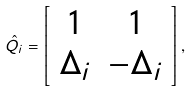Convert formula to latex. <formula><loc_0><loc_0><loc_500><loc_500>\hat { Q } _ { i } = \left [ \begin{array} { c c } 1 & 1 \\ \Delta _ { i } & - \Delta _ { i } \end{array} \right ] ,</formula> 